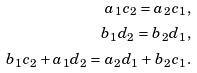Convert formula to latex. <formula><loc_0><loc_0><loc_500><loc_500>a _ { 1 } c _ { 2 } = a _ { 2 } c _ { 1 } , \\ b _ { 1 } d _ { 2 } = b _ { 2 } d _ { 1 } , \\ b _ { 1 } c _ { 2 } + a _ { 1 } d _ { 2 } = a _ { 2 } d _ { 1 } + b _ { 2 } c _ { 1 } .</formula> 